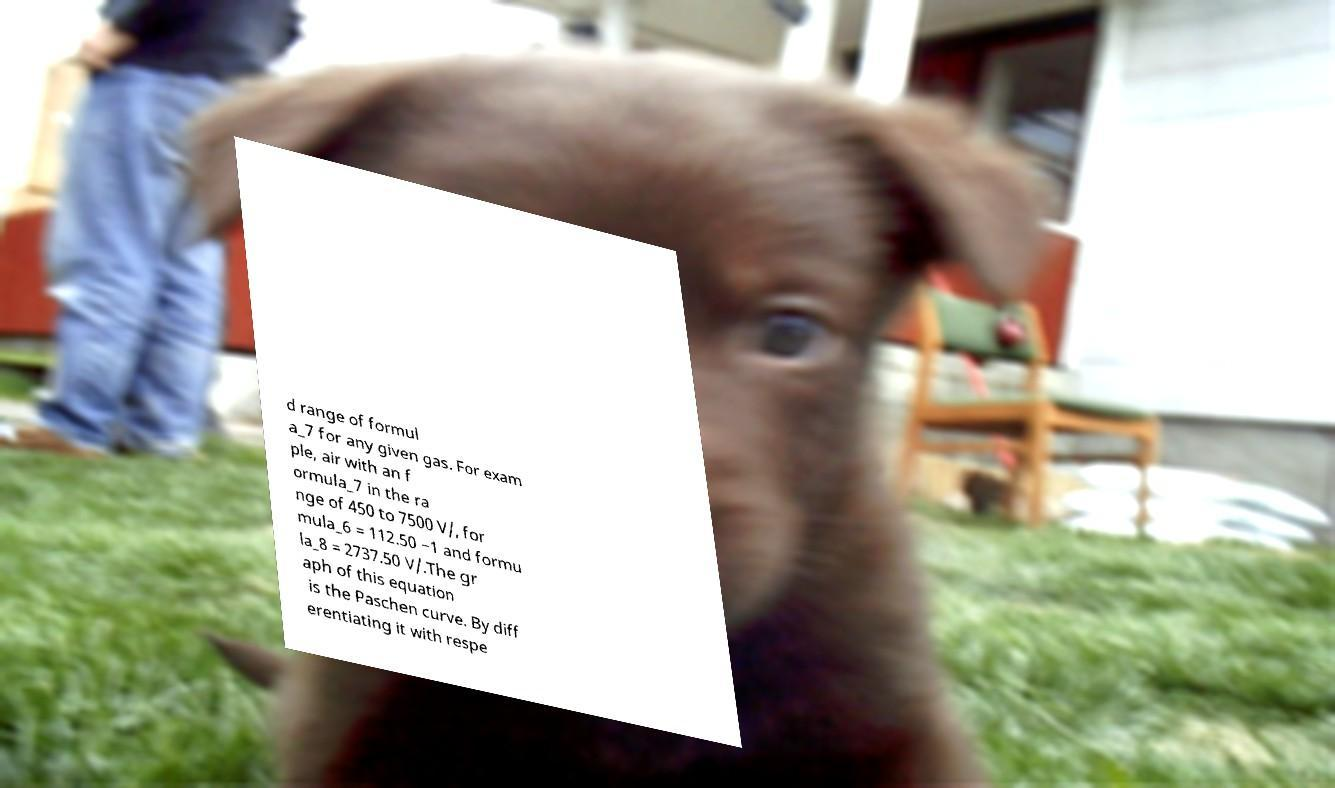Please identify and transcribe the text found in this image. d range of formul a_7 for any given gas. For exam ple, air with an f ormula_7 in the ra nge of 450 to 7500 V/, for mula_6 = 112.50 −1 and formu la_8 = 2737.50 V/.The gr aph of this equation is the Paschen curve. By diff erentiating it with respe 